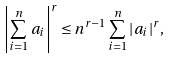<formula> <loc_0><loc_0><loc_500><loc_500>\left | \sum _ { i = 1 } ^ { n } a _ { i } \right | ^ { r } \leq n ^ { r - 1 } \sum _ { i = 1 } ^ { n } | a _ { i } | ^ { r } ,</formula> 